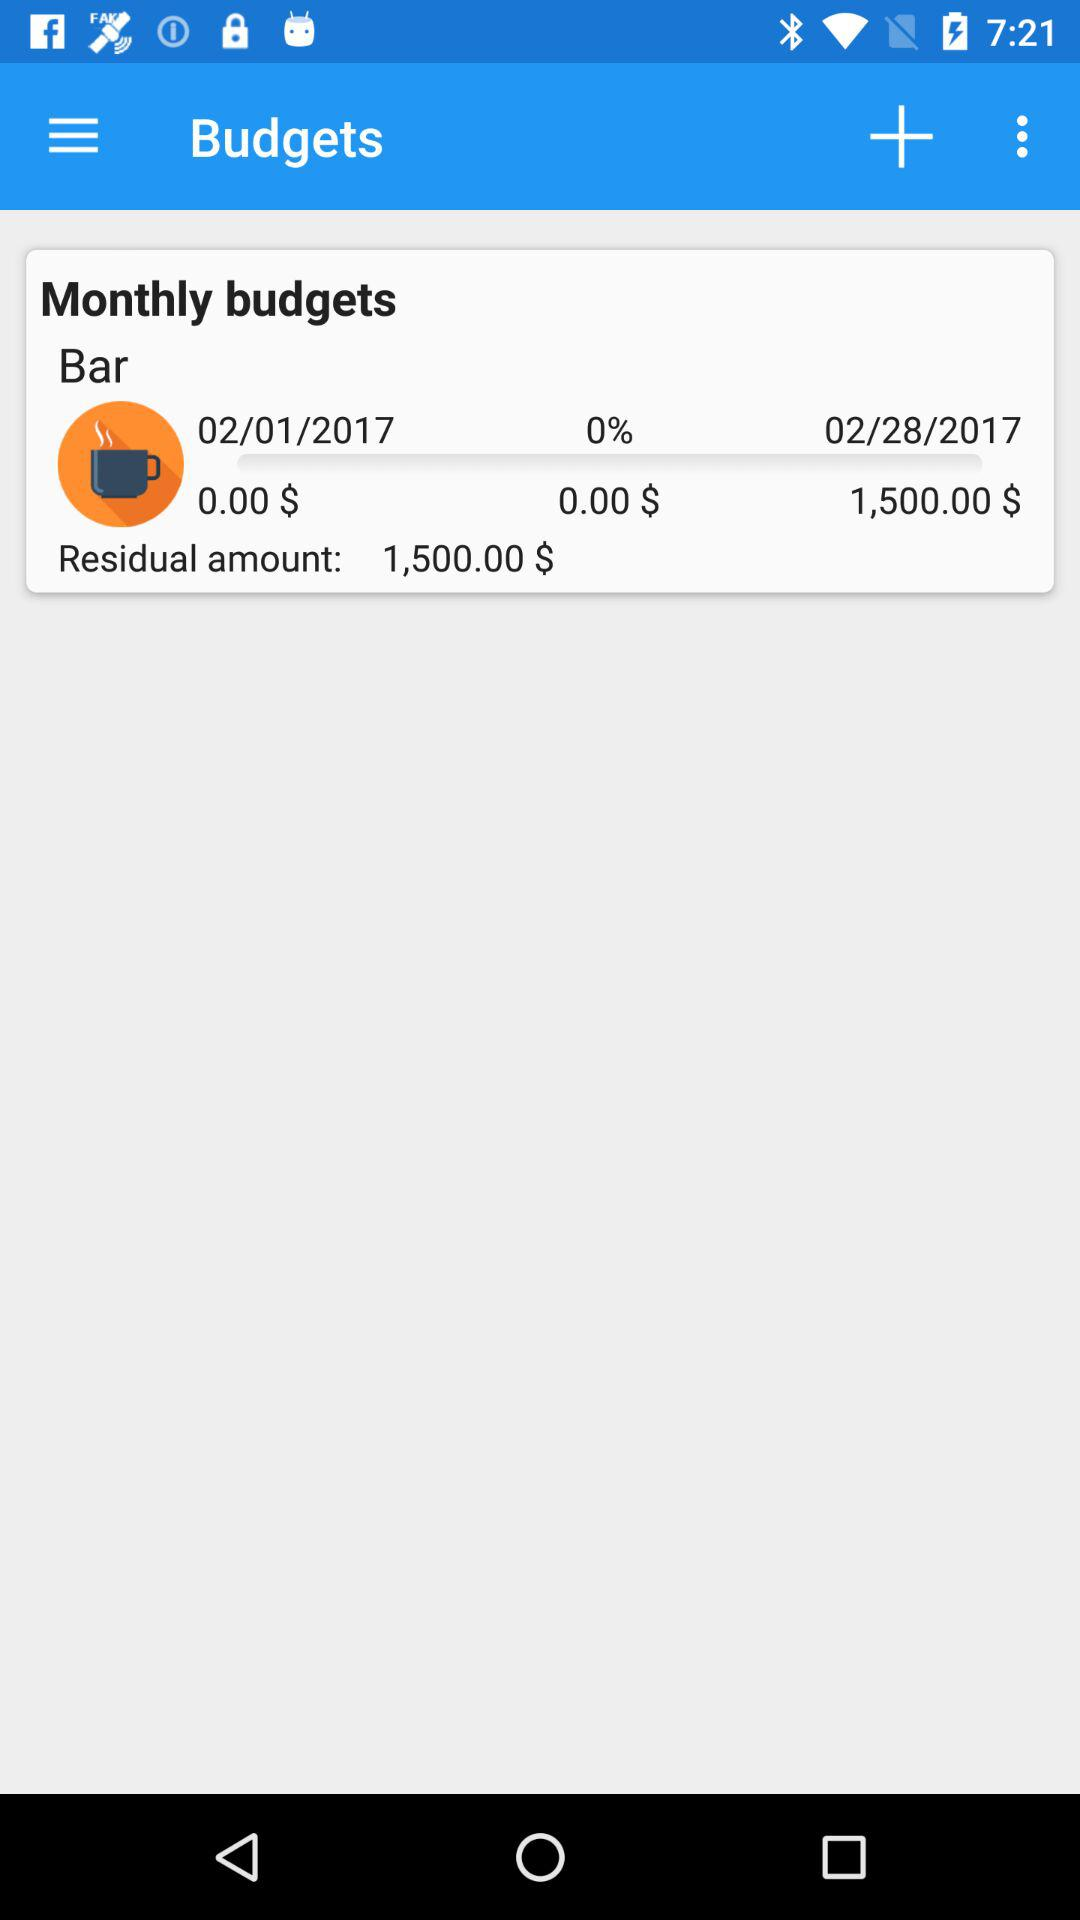What is the residual amount? The residual amount is $1,500. 